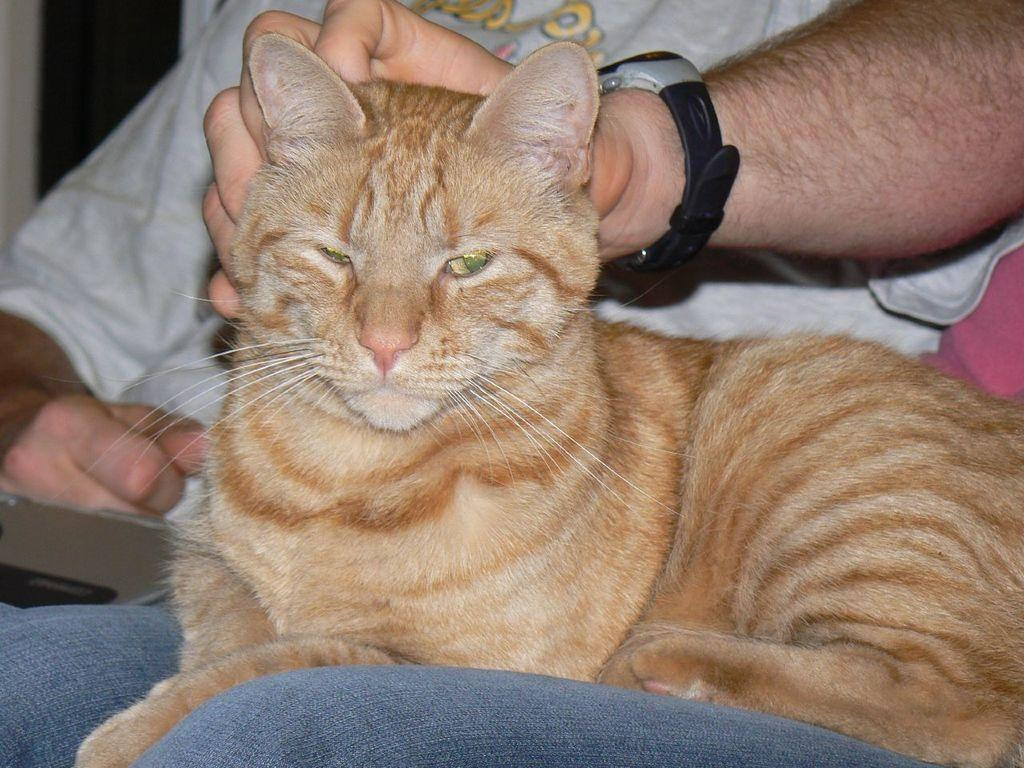What is the main subject of the image? There is a person sitting in the center of the image. What is the person in the center doing? The person is holding a cat. Are there any other people in the image? Yes, there is another person sitting beside the first person. What is the second person wearing? The second person is wearing a white t-shirt. Can you tell me how many deer are visible in the image? There are no deer present in the image. What type of fact can be seen in the image? There is no fact visible in the image; it features a person holding a cat and another person wearing a white t-shirt. 